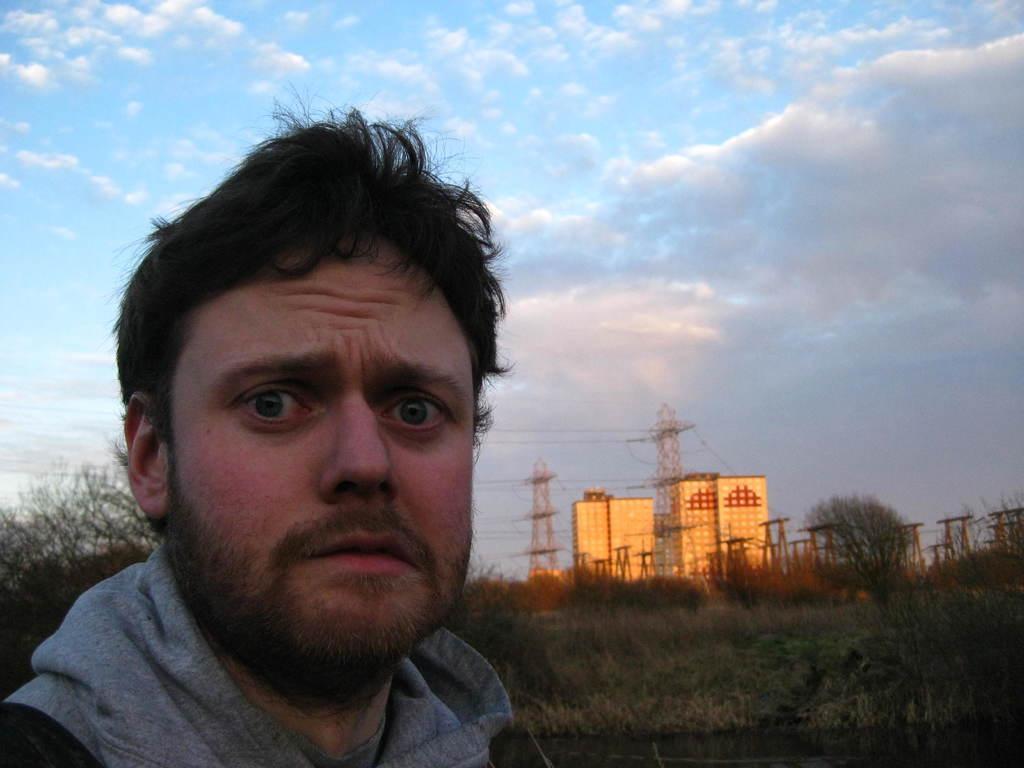How would you summarize this image in a sentence or two? In this picture we can see a man, grass, trees, buildings, towers and in the background we can see the sky with clouds. 